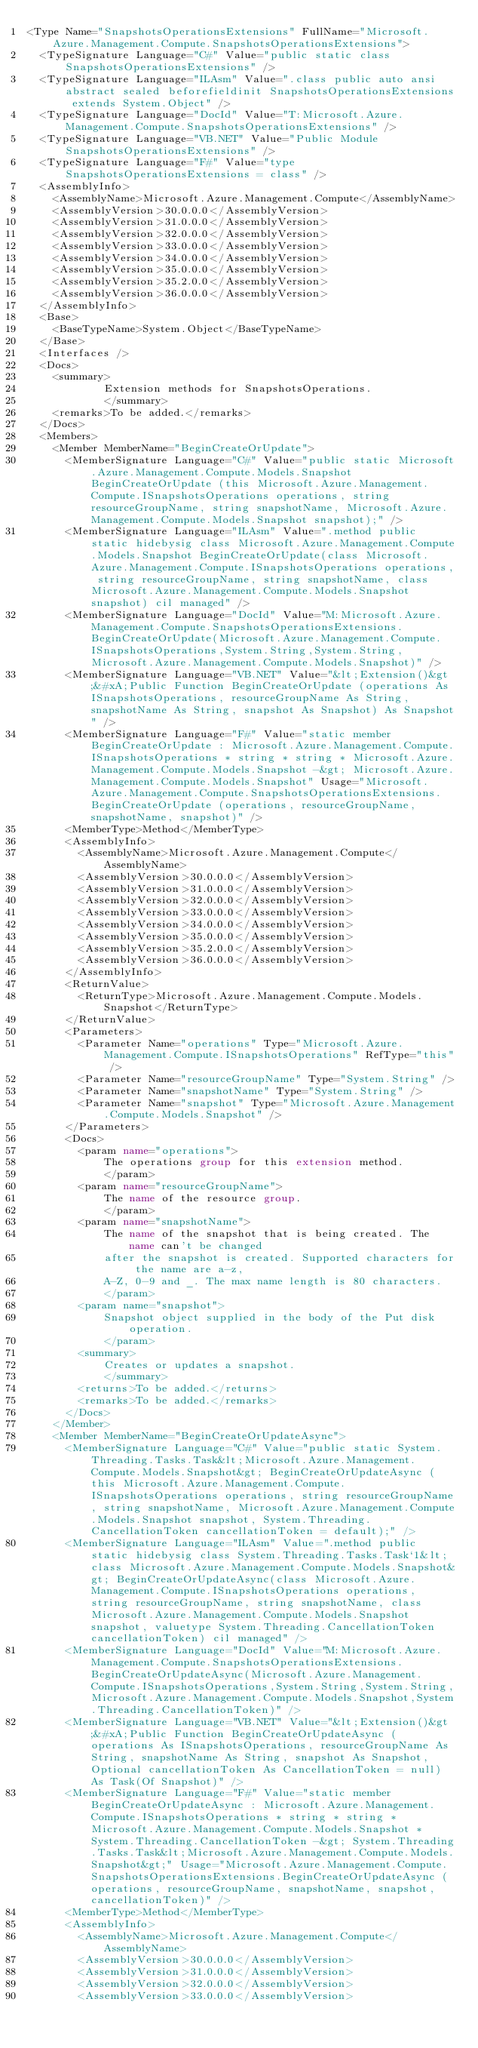<code> <loc_0><loc_0><loc_500><loc_500><_XML_><Type Name="SnapshotsOperationsExtensions" FullName="Microsoft.Azure.Management.Compute.SnapshotsOperationsExtensions">
  <TypeSignature Language="C#" Value="public static class SnapshotsOperationsExtensions" />
  <TypeSignature Language="ILAsm" Value=".class public auto ansi abstract sealed beforefieldinit SnapshotsOperationsExtensions extends System.Object" />
  <TypeSignature Language="DocId" Value="T:Microsoft.Azure.Management.Compute.SnapshotsOperationsExtensions" />
  <TypeSignature Language="VB.NET" Value="Public Module SnapshotsOperationsExtensions" />
  <TypeSignature Language="F#" Value="type SnapshotsOperationsExtensions = class" />
  <AssemblyInfo>
    <AssemblyName>Microsoft.Azure.Management.Compute</AssemblyName>
    <AssemblyVersion>30.0.0.0</AssemblyVersion>
    <AssemblyVersion>31.0.0.0</AssemblyVersion>
    <AssemblyVersion>32.0.0.0</AssemblyVersion>
    <AssemblyVersion>33.0.0.0</AssemblyVersion>
    <AssemblyVersion>34.0.0.0</AssemblyVersion>
    <AssemblyVersion>35.0.0.0</AssemblyVersion>
    <AssemblyVersion>35.2.0.0</AssemblyVersion>
    <AssemblyVersion>36.0.0.0</AssemblyVersion>
  </AssemblyInfo>
  <Base>
    <BaseTypeName>System.Object</BaseTypeName>
  </Base>
  <Interfaces />
  <Docs>
    <summary>
            Extension methods for SnapshotsOperations.
            </summary>
    <remarks>To be added.</remarks>
  </Docs>
  <Members>
    <Member MemberName="BeginCreateOrUpdate">
      <MemberSignature Language="C#" Value="public static Microsoft.Azure.Management.Compute.Models.Snapshot BeginCreateOrUpdate (this Microsoft.Azure.Management.Compute.ISnapshotsOperations operations, string resourceGroupName, string snapshotName, Microsoft.Azure.Management.Compute.Models.Snapshot snapshot);" />
      <MemberSignature Language="ILAsm" Value=".method public static hidebysig class Microsoft.Azure.Management.Compute.Models.Snapshot BeginCreateOrUpdate(class Microsoft.Azure.Management.Compute.ISnapshotsOperations operations, string resourceGroupName, string snapshotName, class Microsoft.Azure.Management.Compute.Models.Snapshot snapshot) cil managed" />
      <MemberSignature Language="DocId" Value="M:Microsoft.Azure.Management.Compute.SnapshotsOperationsExtensions.BeginCreateOrUpdate(Microsoft.Azure.Management.Compute.ISnapshotsOperations,System.String,System.String,Microsoft.Azure.Management.Compute.Models.Snapshot)" />
      <MemberSignature Language="VB.NET" Value="&lt;Extension()&gt;&#xA;Public Function BeginCreateOrUpdate (operations As ISnapshotsOperations, resourceGroupName As String, snapshotName As String, snapshot As Snapshot) As Snapshot" />
      <MemberSignature Language="F#" Value="static member BeginCreateOrUpdate : Microsoft.Azure.Management.Compute.ISnapshotsOperations * string * string * Microsoft.Azure.Management.Compute.Models.Snapshot -&gt; Microsoft.Azure.Management.Compute.Models.Snapshot" Usage="Microsoft.Azure.Management.Compute.SnapshotsOperationsExtensions.BeginCreateOrUpdate (operations, resourceGroupName, snapshotName, snapshot)" />
      <MemberType>Method</MemberType>
      <AssemblyInfo>
        <AssemblyName>Microsoft.Azure.Management.Compute</AssemblyName>
        <AssemblyVersion>30.0.0.0</AssemblyVersion>
        <AssemblyVersion>31.0.0.0</AssemblyVersion>
        <AssemblyVersion>32.0.0.0</AssemblyVersion>
        <AssemblyVersion>33.0.0.0</AssemblyVersion>
        <AssemblyVersion>34.0.0.0</AssemblyVersion>
        <AssemblyVersion>35.0.0.0</AssemblyVersion>
        <AssemblyVersion>35.2.0.0</AssemblyVersion>
        <AssemblyVersion>36.0.0.0</AssemblyVersion>
      </AssemblyInfo>
      <ReturnValue>
        <ReturnType>Microsoft.Azure.Management.Compute.Models.Snapshot</ReturnType>
      </ReturnValue>
      <Parameters>
        <Parameter Name="operations" Type="Microsoft.Azure.Management.Compute.ISnapshotsOperations" RefType="this" />
        <Parameter Name="resourceGroupName" Type="System.String" />
        <Parameter Name="snapshotName" Type="System.String" />
        <Parameter Name="snapshot" Type="Microsoft.Azure.Management.Compute.Models.Snapshot" />
      </Parameters>
      <Docs>
        <param name="operations">
            The operations group for this extension method.
            </param>
        <param name="resourceGroupName">
            The name of the resource group.
            </param>
        <param name="snapshotName">
            The name of the snapshot that is being created. The name can't be changed
            after the snapshot is created. Supported characters for the name are a-z,
            A-Z, 0-9 and _. The max name length is 80 characters.
            </param>
        <param name="snapshot">
            Snapshot object supplied in the body of the Put disk operation.
            </param>
        <summary>
            Creates or updates a snapshot.
            </summary>
        <returns>To be added.</returns>
        <remarks>To be added.</remarks>
      </Docs>
    </Member>
    <Member MemberName="BeginCreateOrUpdateAsync">
      <MemberSignature Language="C#" Value="public static System.Threading.Tasks.Task&lt;Microsoft.Azure.Management.Compute.Models.Snapshot&gt; BeginCreateOrUpdateAsync (this Microsoft.Azure.Management.Compute.ISnapshotsOperations operations, string resourceGroupName, string snapshotName, Microsoft.Azure.Management.Compute.Models.Snapshot snapshot, System.Threading.CancellationToken cancellationToken = default);" />
      <MemberSignature Language="ILAsm" Value=".method public static hidebysig class System.Threading.Tasks.Task`1&lt;class Microsoft.Azure.Management.Compute.Models.Snapshot&gt; BeginCreateOrUpdateAsync(class Microsoft.Azure.Management.Compute.ISnapshotsOperations operations, string resourceGroupName, string snapshotName, class Microsoft.Azure.Management.Compute.Models.Snapshot snapshot, valuetype System.Threading.CancellationToken cancellationToken) cil managed" />
      <MemberSignature Language="DocId" Value="M:Microsoft.Azure.Management.Compute.SnapshotsOperationsExtensions.BeginCreateOrUpdateAsync(Microsoft.Azure.Management.Compute.ISnapshotsOperations,System.String,System.String,Microsoft.Azure.Management.Compute.Models.Snapshot,System.Threading.CancellationToken)" />
      <MemberSignature Language="VB.NET" Value="&lt;Extension()&gt;&#xA;Public Function BeginCreateOrUpdateAsync (operations As ISnapshotsOperations, resourceGroupName As String, snapshotName As String, snapshot As Snapshot, Optional cancellationToken As CancellationToken = null) As Task(Of Snapshot)" />
      <MemberSignature Language="F#" Value="static member BeginCreateOrUpdateAsync : Microsoft.Azure.Management.Compute.ISnapshotsOperations * string * string * Microsoft.Azure.Management.Compute.Models.Snapshot * System.Threading.CancellationToken -&gt; System.Threading.Tasks.Task&lt;Microsoft.Azure.Management.Compute.Models.Snapshot&gt;" Usage="Microsoft.Azure.Management.Compute.SnapshotsOperationsExtensions.BeginCreateOrUpdateAsync (operations, resourceGroupName, snapshotName, snapshot, cancellationToken)" />
      <MemberType>Method</MemberType>
      <AssemblyInfo>
        <AssemblyName>Microsoft.Azure.Management.Compute</AssemblyName>
        <AssemblyVersion>30.0.0.0</AssemblyVersion>
        <AssemblyVersion>31.0.0.0</AssemblyVersion>
        <AssemblyVersion>32.0.0.0</AssemblyVersion>
        <AssemblyVersion>33.0.0.0</AssemblyVersion></code> 